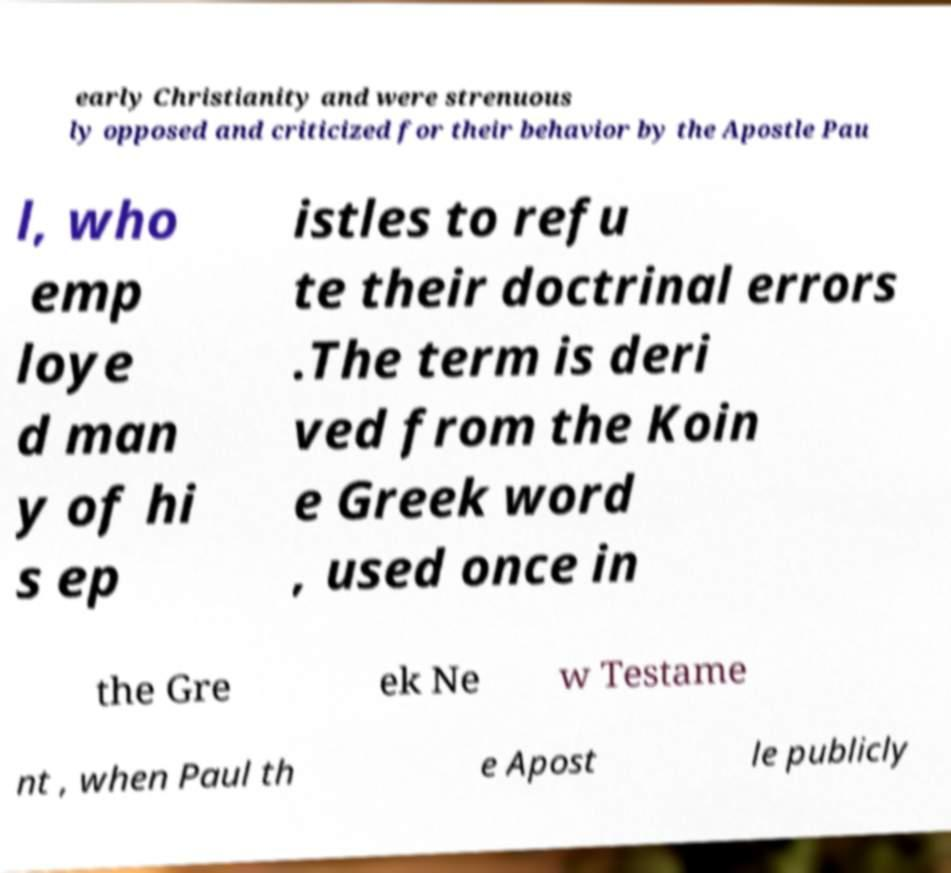Please read and relay the text visible in this image. What does it say? early Christianity and were strenuous ly opposed and criticized for their behavior by the Apostle Pau l, who emp loye d man y of hi s ep istles to refu te their doctrinal errors .The term is deri ved from the Koin e Greek word , used once in the Gre ek Ne w Testame nt , when Paul th e Apost le publicly 